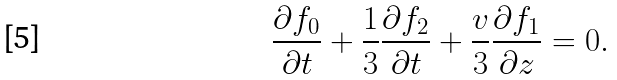Convert formula to latex. <formula><loc_0><loc_0><loc_500><loc_500>\frac { \partial f _ { 0 } } { \partial t } + \frac { 1 } { 3 } \frac { \partial f _ { 2 } } { \partial t } + \frac { v } { 3 } \frac { \partial f _ { 1 } } { \partial z } = 0 .</formula> 